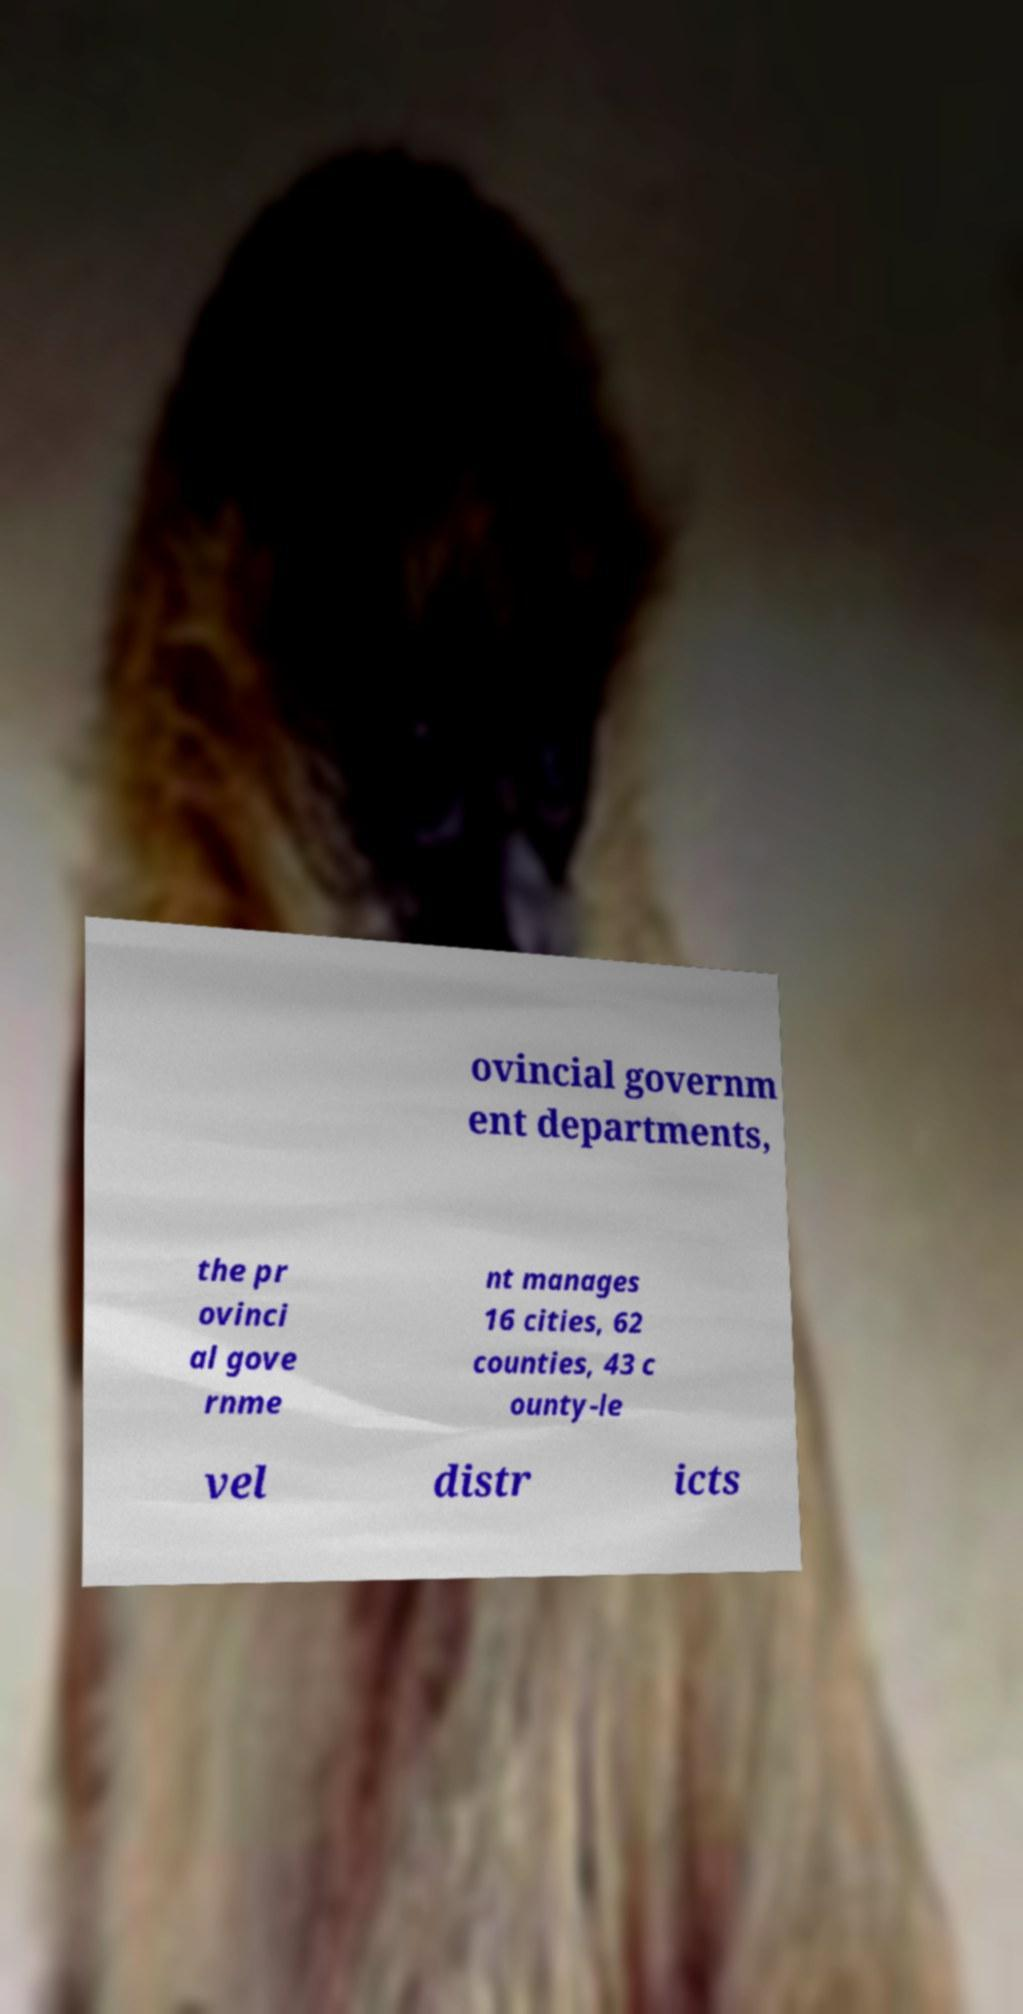Please read and relay the text visible in this image. What does it say? ovincial governm ent departments, the pr ovinci al gove rnme nt manages 16 cities, 62 counties, 43 c ounty-le vel distr icts 